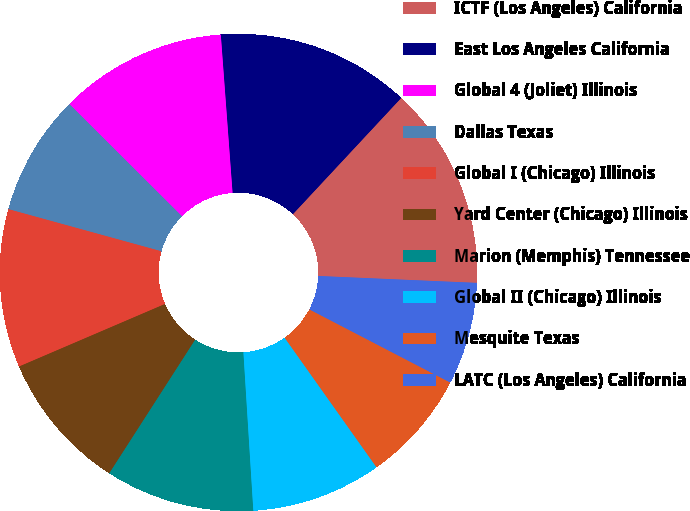Convert chart. <chart><loc_0><loc_0><loc_500><loc_500><pie_chart><fcel>ICTF (Los Angeles) California<fcel>East Los Angeles California<fcel>Global 4 (Joliet) Illinois<fcel>Dallas Texas<fcel>Global I (Chicago) Illinois<fcel>Yard Center (Chicago) Illinois<fcel>Marion (Memphis) Tennessee<fcel>Global II (Chicago) Illinois<fcel>Mesquite Texas<fcel>LATC (Los Angeles) California<nl><fcel>13.75%<fcel>13.12%<fcel>11.35%<fcel>8.19%<fcel>10.72%<fcel>9.46%<fcel>10.09%<fcel>8.82%<fcel>7.56%<fcel>6.93%<nl></chart> 